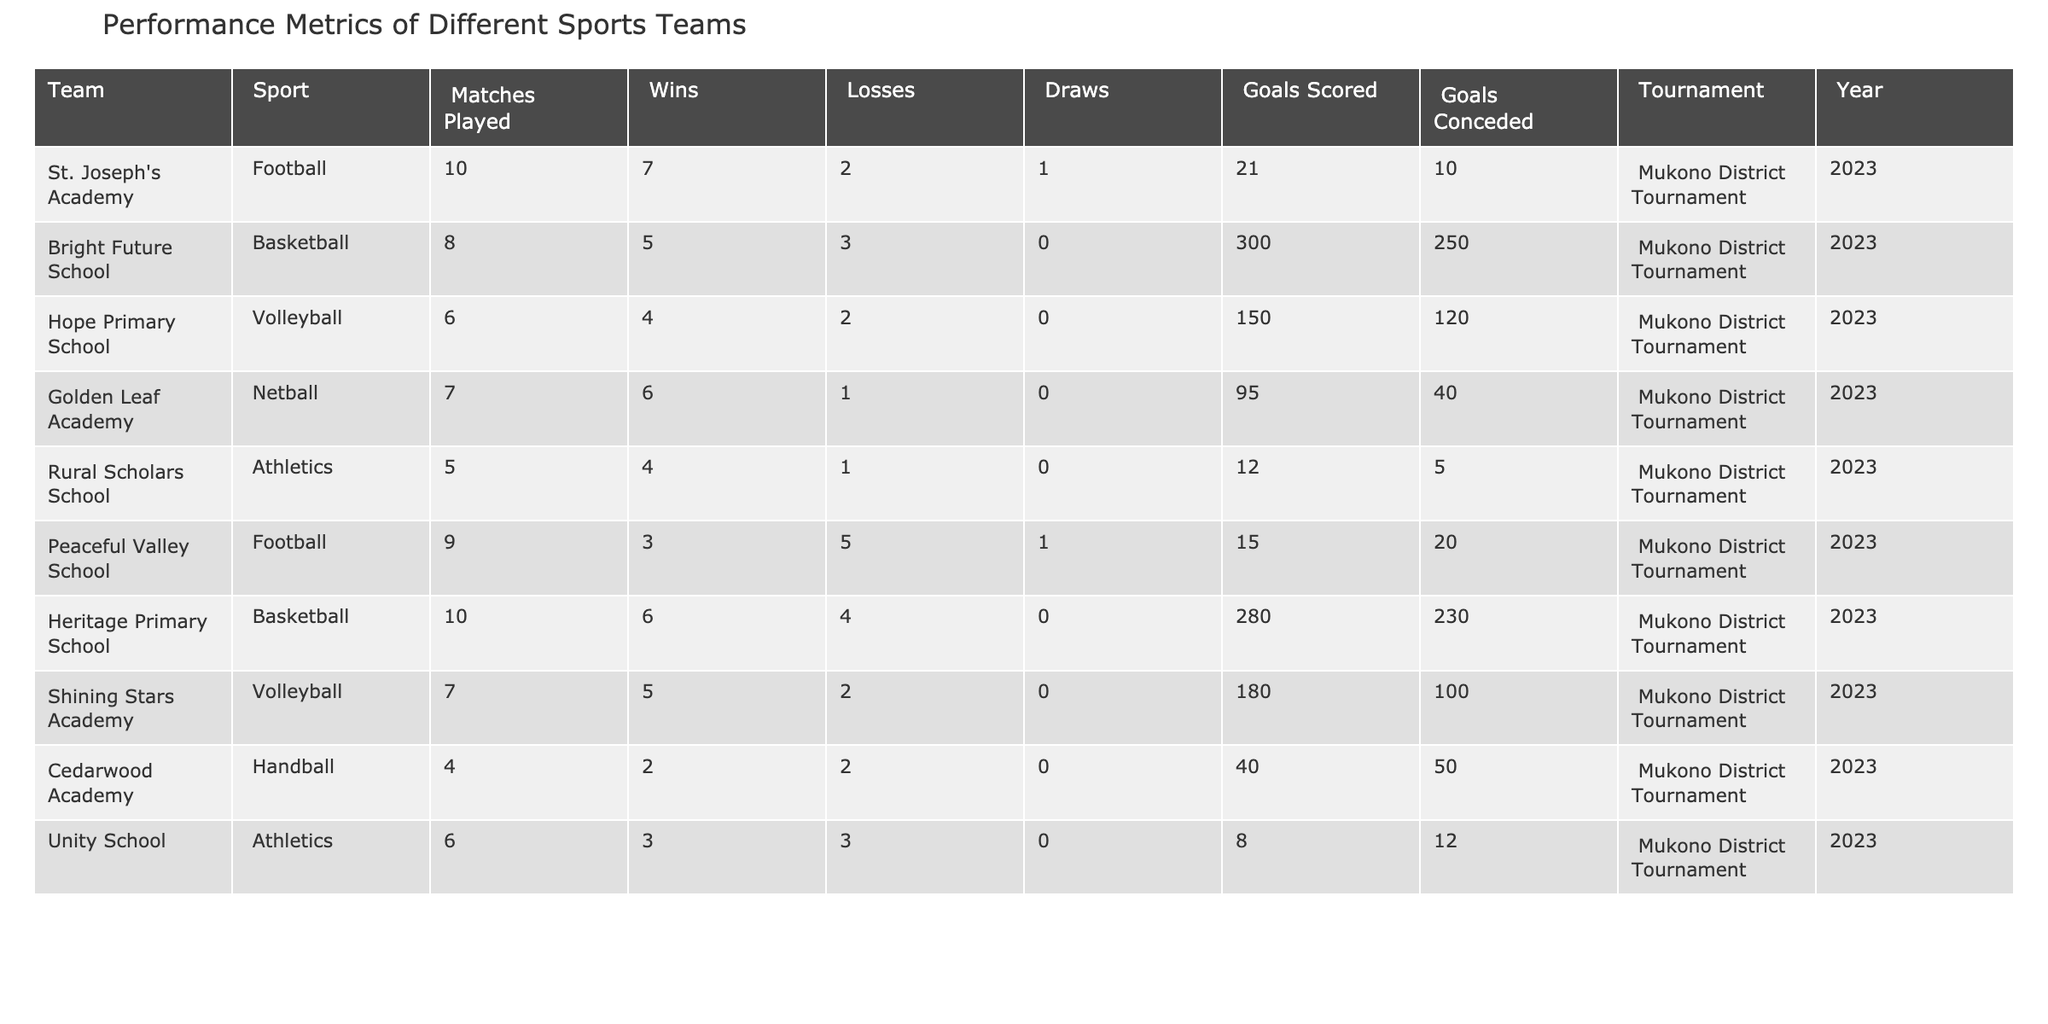What team had the highest number of wins? By reviewing the "Wins" column, St. Joseph's Academy had 7 wins, Golden Leaf Academy had 6 wins, and no other team exceeded that. Therefore, St. Joseph's Academy holds the record for the highest number of wins.
Answer: St. Joseph's Academy How many total matches were played by all teams combined? Summing the "Matches Played" for all teams: 10 + 8 + 6 + 7 + 5 + 9 + 10 + 7 + 4 + 6 = 72 total matches were played.
Answer: 72 What is the goal difference for the Bright Future School basketball team? The goal difference is calculated by subtracting "Goals Conceded" from "Goals Scored": 300 - 250 = 50. Thus, the goal difference for Bright Future School is 50.
Answer: 50 Which team had the lowest goals scored? Looking at the "Goals Scored" column, Unity School scored the lowest with 8 goals. Therefore, Unity School had the lowest goals scored.
Answer: Unity School Which sport had the most teams participating in the tournament? Examining the "Sport" column, Football, Basketball, Volleyball, Netball, and Athletics each had two teams participating. Thus, Football and Basketball had the most teams.
Answer: Football and Basketball What was the average number of goals scored by the teams that won more than 5 matches? Only Golden Leaf Academy (6 goals) and St. Joseph's Academy (21 goals) won more than 5 matches. The average is (21 + 95)/2 = 58.
Answer: 58 Did Peaceful Valley School achieve more wins than losses? By reviewing the "Wins" and "Losses" columns for Peaceful Valley School, they won 3 matches and lost 5. Therefore, they did not achieve more wins than losses.
Answer: No Which team or teams had the highest goals conceded? Peaceful Valley School conceded 20 goals, which is the highest compared to other teams. Therefore, they had the highest goals conceded.
Answer: Peaceful Valley School What is the total number of goals scored by all volleyball teams? Adding the goals scored by the Volleyball teams: Hope Primary School (150) and Shining Stars Academy (180) gives a total of 150 + 180 = 330 goals.
Answer: 330 How many teams had a record of exactly 3 wins? Only one team has a record of exactly 3 wins: Peaceful Valley School. Therefore, there is 1 team with exactly 3 wins.
Answer: 1 